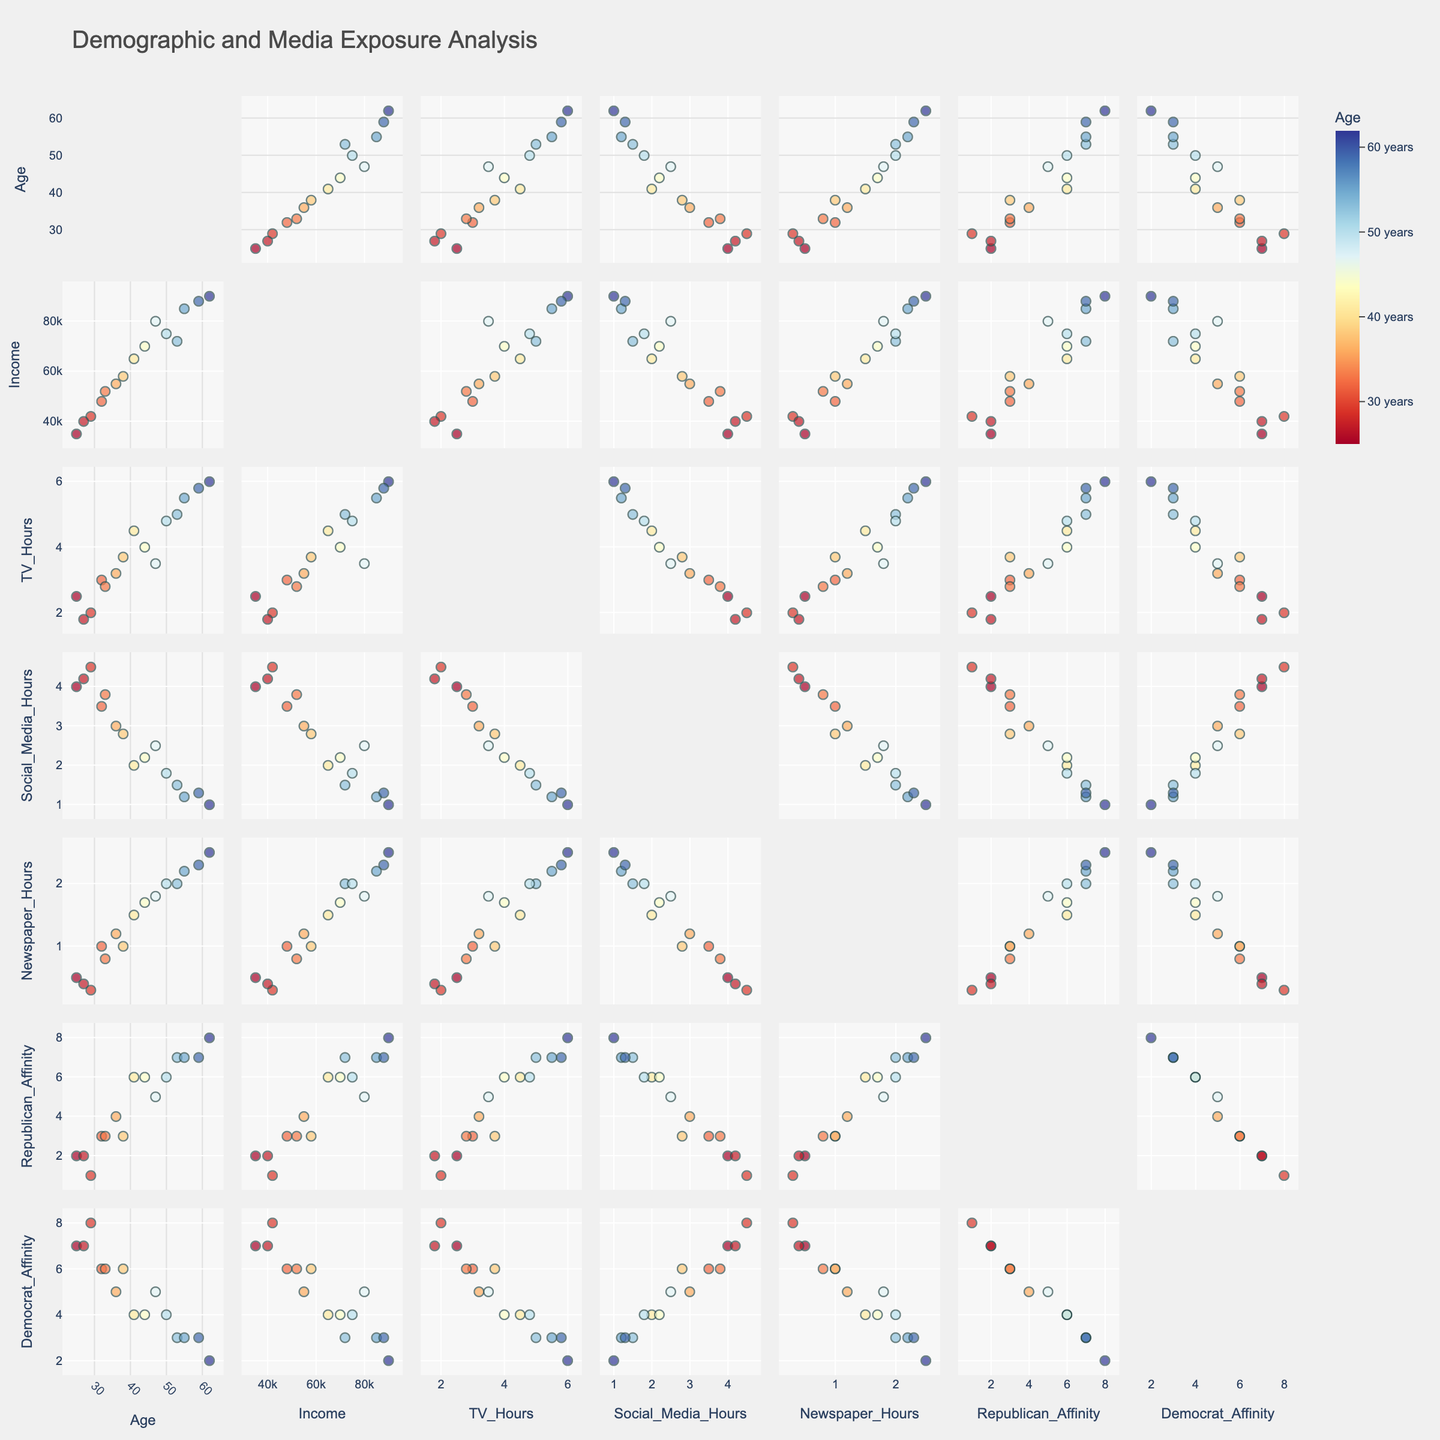What's the title of the figure? The title is displayed prominently at the top of the figure, typically in a larger font for visibility.
Answer: Demographic and Media Exposure Analysis What is the color scale representing? The color scale is shown alongside the plot and indicates the range of values it represents. Here, it relates to 'Age', with colors varying across the age range specified.
Answer: Age How many dimensions are analyzed in the scatterplot matrix? The scatterplot matrix includes plots for each combination of the provided dimensions. Counting the axes or the labels will give the number of dimensions.
Answer: 7 What is the general trend between TV_Hours and Republican_Affinity? Look at the plots where 'TV_Hours' is on one axis and 'Republican_Affinity' is on the other. Observe the clustering pattern of the data points.
Answer: Positive correlation Which two dimensions show the highest diversity in their relationship? Examine the scatter plots for the spread and range of the points. The highest diversity will be where points cover the widest range.
Answer: Age and Income Is there a visible pattern indicating older individuals have higher Republican_Affinity? By examining the scatter plots where 'Age' and 'Republican_Affinity' are plotted against each other, check if older age groups show a trend of higher Republican_Affinity.
Answer: Yes Are TV_Hours and Newspaper_Hours positively correlated? Identify the scatter plot that relates 'TV_Hours' and 'Newspaper_Hours' and check the direction of the data points to determine the correlation.
Answer: Yes Which dimension shows least variation with 'Age'? Look for the scatter plots of 'Age' with each other dimension and check where the points form a horizontal or tightly grouped pattern.
Answer: Social_Media_Hours How does Democrat_Affinity generally vary with Income? Observing the scatter plots of 'Income' against 'Democrat_Affinity', look for any upward or downward trend.
Answer: Weak negative correlation Are there clusters of individuals who both have high Social_Media_Hours and high Democrat_Affinity? In the scatter plot that includes 'Social_Media_Hours' and 'Democrat_Affinity', check if there is a noticeable grouping of points at high values for both axes.
Answer: Yes 